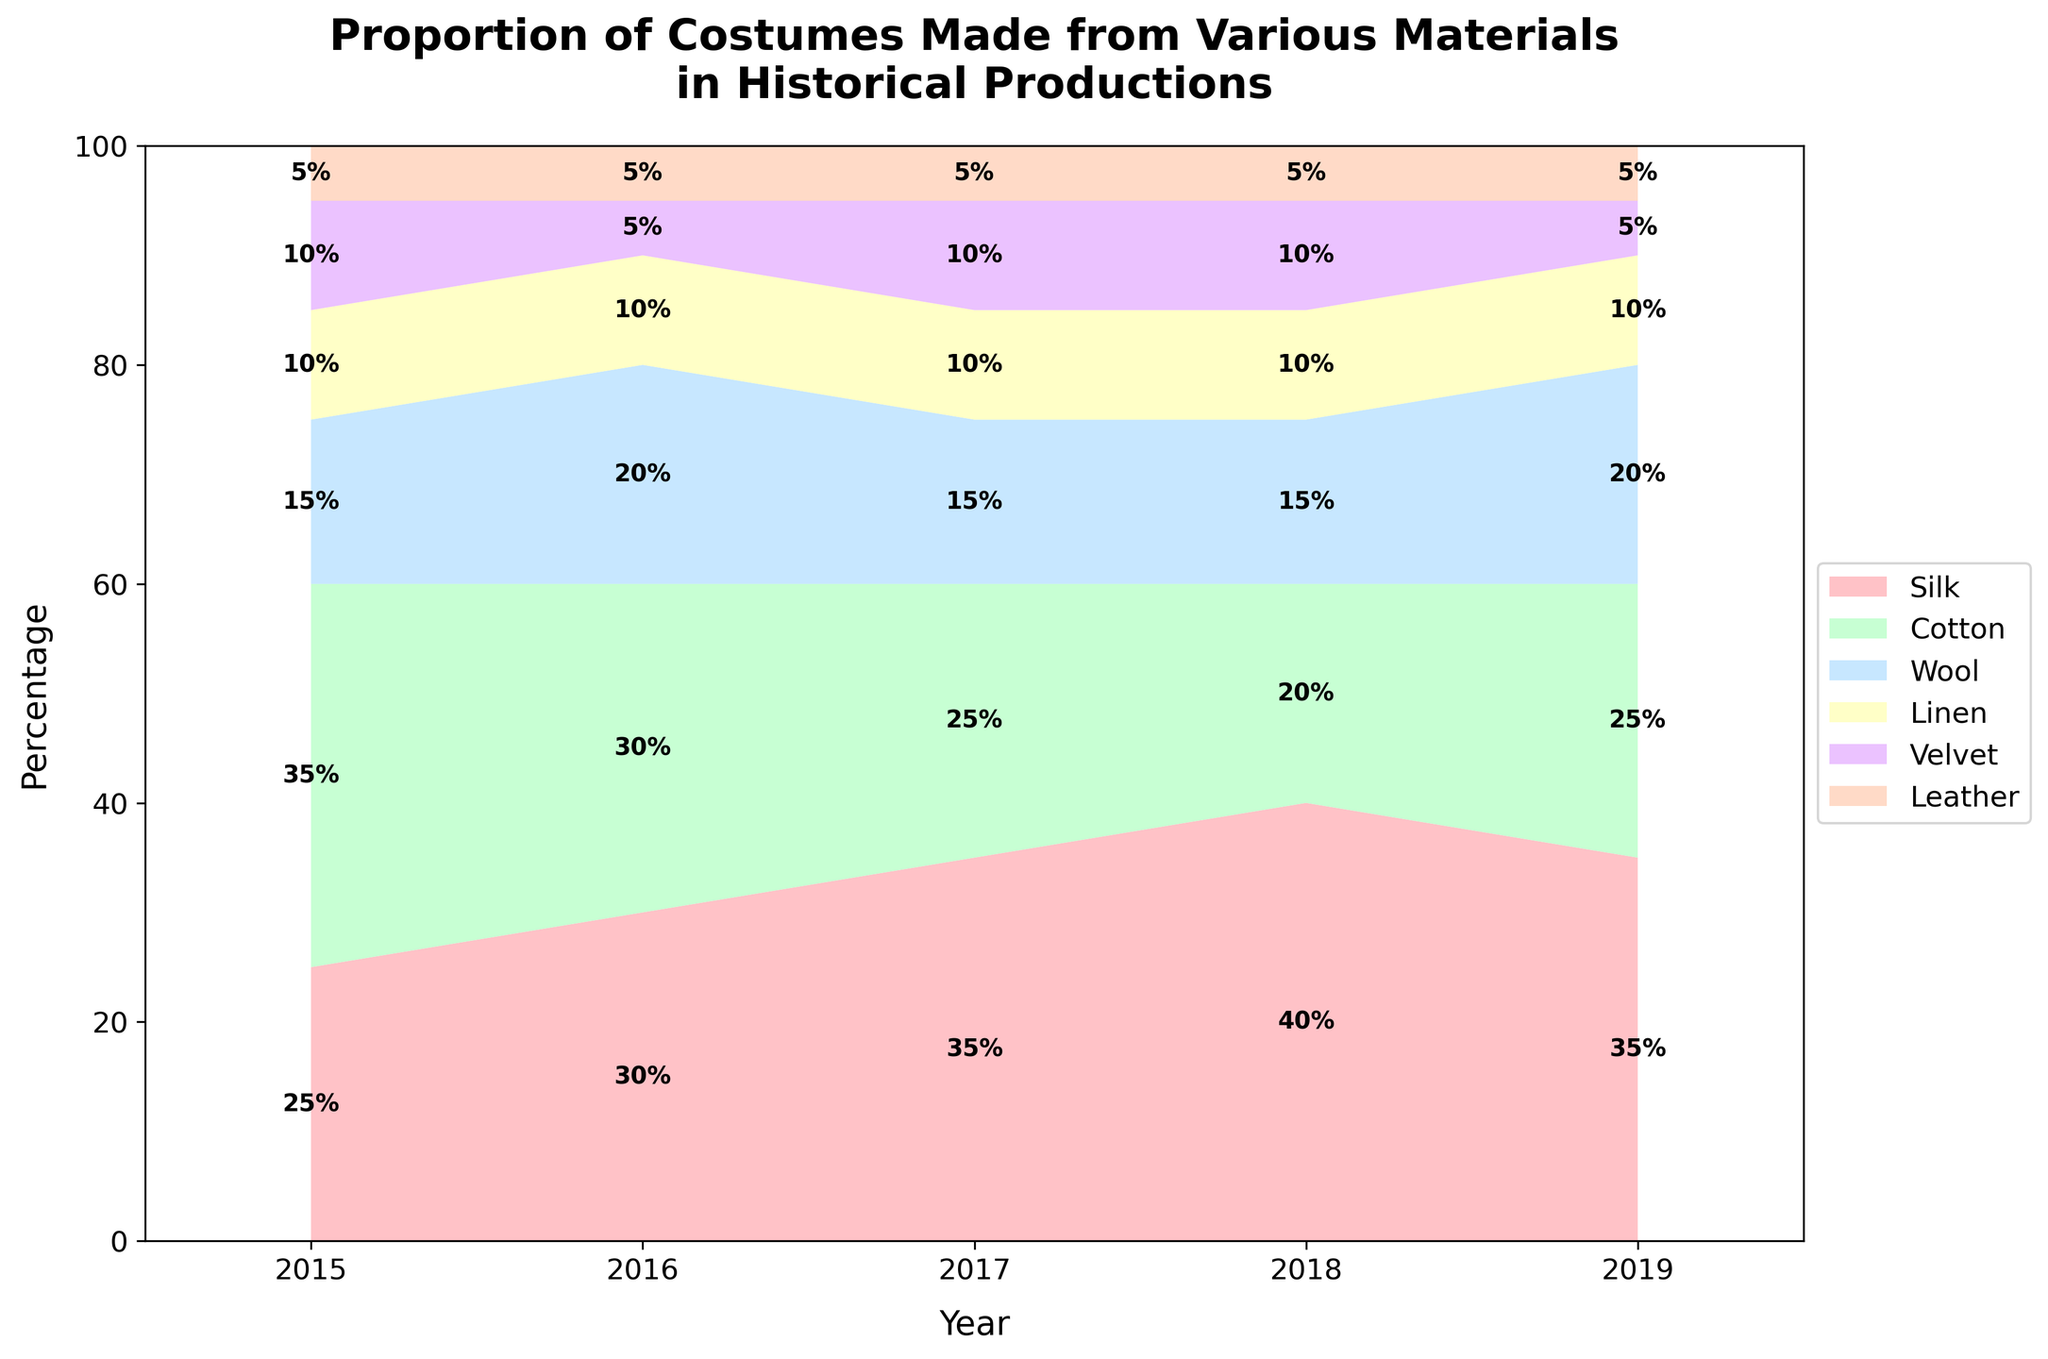What is the title of the chart? The title of the chart is displayed at the top and describes the content of the chart. The title is "Proportion of Costumes Made from Various Materials in Historical Productions".
Answer: Proportion of Costumes Made from Various Materials in Historical Productions Which material had the highest percentage in 2016? By looking at the stacked segments for the year 2016, the segment for Silk is the largest. Thus, Silk had the highest percentage in 2016.
Answer: Silk How did the percentage of Wool change from 2015 to 2019? First refer to the percentage of Wool in 2015 (15%) and compare it to the percentage in 2019 (20%). It increased by 5%.
Answer: Increased by 5% What were the percentages of Leather each year? The percentages of Leather in each year can be observed from the figure: 2015 - 5%, 2016 - 5%, 2017 - 5%, 2018 - 5%, 2019 - 5%.
Answer: 5% each year Which material showed a consistent percentage throughout the years? Leather maintains a consistent percentage of 5% across all the years (2015-2019).
Answer: Leather Compare the proportions of Velvet and Linen in 2018. Which was higher? Refer to the year 2018 and compare the segments of Velvet (10%) and Linen (10%). Both proportions are the same.
Answer: Equal What is the combined percentage of Cotton and Silk in 2017? For the year 2017, the percentage of Cotton is 25% and Silk is 35%. Adding them together, 25% + 35% = 60%.
Answer: 60% Between 2015 and 2019, did Velvet's percentage ever surpass that of Linen? By comparing the percentages across all years, Velvet (5%-10%) never surpasses Linen (10%) in any given year.
Answer: No What trend is observed for Silk from 2015 to 2018? By observing the Silk segments from 2015 (25%) to 2018 (40%), it shows an increasing trend.
Answer: Increasing 